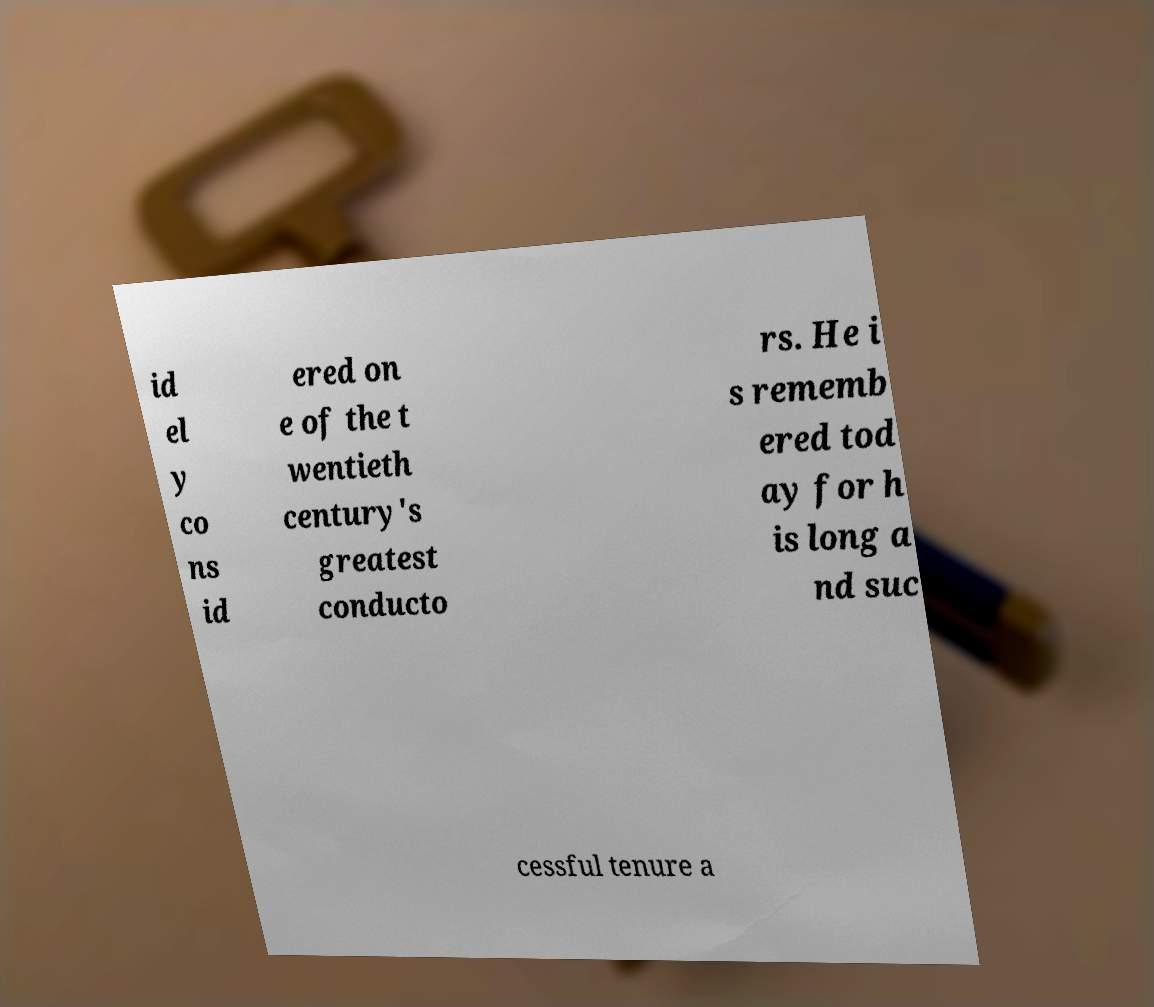For documentation purposes, I need the text within this image transcribed. Could you provide that? id el y co ns id ered on e of the t wentieth century's greatest conducto rs. He i s rememb ered tod ay for h is long a nd suc cessful tenure a 